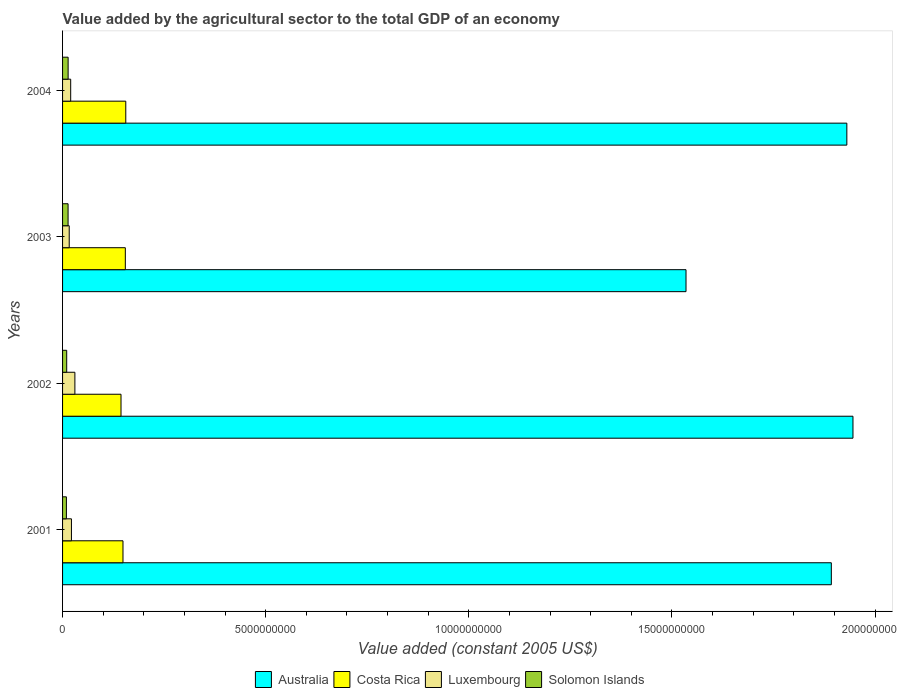How many groups of bars are there?
Provide a succinct answer. 4. Are the number of bars per tick equal to the number of legend labels?
Your answer should be very brief. Yes. Are the number of bars on each tick of the Y-axis equal?
Offer a terse response. Yes. What is the label of the 1st group of bars from the top?
Keep it short and to the point. 2004. In how many cases, is the number of bars for a given year not equal to the number of legend labels?
Provide a succinct answer. 0. What is the value added by the agricultural sector in Solomon Islands in 2001?
Offer a terse response. 9.47e+07. Across all years, what is the maximum value added by the agricultural sector in Costa Rica?
Make the answer very short. 1.56e+09. Across all years, what is the minimum value added by the agricultural sector in Luxembourg?
Provide a succinct answer. 1.64e+08. In which year was the value added by the agricultural sector in Australia minimum?
Ensure brevity in your answer.  2003. What is the total value added by the agricultural sector in Australia in the graph?
Offer a very short reply. 7.30e+1. What is the difference between the value added by the agricultural sector in Luxembourg in 2001 and that in 2003?
Provide a succinct answer. 5.45e+07. What is the difference between the value added by the agricultural sector in Solomon Islands in 2004 and the value added by the agricultural sector in Costa Rica in 2002?
Your answer should be very brief. -1.30e+09. What is the average value added by the agricultural sector in Australia per year?
Your answer should be very brief. 1.83e+1. In the year 2003, what is the difference between the value added by the agricultural sector in Costa Rica and value added by the agricultural sector in Solomon Islands?
Offer a very short reply. 1.41e+09. What is the ratio of the value added by the agricultural sector in Luxembourg in 2003 to that in 2004?
Provide a succinct answer. 0.82. Is the value added by the agricultural sector in Luxembourg in 2001 less than that in 2004?
Offer a very short reply. No. Is the difference between the value added by the agricultural sector in Costa Rica in 2001 and 2002 greater than the difference between the value added by the agricultural sector in Solomon Islands in 2001 and 2002?
Ensure brevity in your answer.  Yes. What is the difference between the highest and the second highest value added by the agricultural sector in Solomon Islands?
Give a very brief answer. 1.15e+06. What is the difference between the highest and the lowest value added by the agricultural sector in Luxembourg?
Provide a succinct answer. 1.39e+08. In how many years, is the value added by the agricultural sector in Costa Rica greater than the average value added by the agricultural sector in Costa Rica taken over all years?
Make the answer very short. 2. Is it the case that in every year, the sum of the value added by the agricultural sector in Costa Rica and value added by the agricultural sector in Solomon Islands is greater than the sum of value added by the agricultural sector in Australia and value added by the agricultural sector in Luxembourg?
Offer a very short reply. Yes. What does the 3rd bar from the top in 2003 represents?
Keep it short and to the point. Costa Rica. What does the 3rd bar from the bottom in 2001 represents?
Offer a terse response. Luxembourg. Is it the case that in every year, the sum of the value added by the agricultural sector in Solomon Islands and value added by the agricultural sector in Australia is greater than the value added by the agricultural sector in Costa Rica?
Make the answer very short. Yes. Are all the bars in the graph horizontal?
Keep it short and to the point. Yes. Does the graph contain grids?
Offer a very short reply. No. What is the title of the graph?
Provide a succinct answer. Value added by the agricultural sector to the total GDP of an economy. Does "Marshall Islands" appear as one of the legend labels in the graph?
Your answer should be compact. No. What is the label or title of the X-axis?
Give a very brief answer. Value added (constant 2005 US$). What is the Value added (constant 2005 US$) of Australia in 2001?
Provide a succinct answer. 1.89e+1. What is the Value added (constant 2005 US$) in Costa Rica in 2001?
Ensure brevity in your answer.  1.49e+09. What is the Value added (constant 2005 US$) of Luxembourg in 2001?
Ensure brevity in your answer.  2.18e+08. What is the Value added (constant 2005 US$) in Solomon Islands in 2001?
Offer a terse response. 9.47e+07. What is the Value added (constant 2005 US$) in Australia in 2002?
Offer a terse response. 1.95e+1. What is the Value added (constant 2005 US$) of Costa Rica in 2002?
Offer a terse response. 1.44e+09. What is the Value added (constant 2005 US$) of Luxembourg in 2002?
Keep it short and to the point. 3.03e+08. What is the Value added (constant 2005 US$) in Solomon Islands in 2002?
Provide a short and direct response. 1.02e+08. What is the Value added (constant 2005 US$) of Australia in 2003?
Your answer should be very brief. 1.53e+1. What is the Value added (constant 2005 US$) of Costa Rica in 2003?
Offer a very short reply. 1.54e+09. What is the Value added (constant 2005 US$) in Luxembourg in 2003?
Provide a short and direct response. 1.64e+08. What is the Value added (constant 2005 US$) in Solomon Islands in 2003?
Your response must be concise. 1.36e+08. What is the Value added (constant 2005 US$) of Australia in 2004?
Your answer should be compact. 1.93e+1. What is the Value added (constant 2005 US$) in Costa Rica in 2004?
Provide a succinct answer. 1.56e+09. What is the Value added (constant 2005 US$) of Luxembourg in 2004?
Give a very brief answer. 2.00e+08. What is the Value added (constant 2005 US$) in Solomon Islands in 2004?
Offer a terse response. 1.37e+08. Across all years, what is the maximum Value added (constant 2005 US$) of Australia?
Give a very brief answer. 1.95e+1. Across all years, what is the maximum Value added (constant 2005 US$) of Costa Rica?
Provide a short and direct response. 1.56e+09. Across all years, what is the maximum Value added (constant 2005 US$) of Luxembourg?
Offer a terse response. 3.03e+08. Across all years, what is the maximum Value added (constant 2005 US$) in Solomon Islands?
Make the answer very short. 1.37e+08. Across all years, what is the minimum Value added (constant 2005 US$) of Australia?
Keep it short and to the point. 1.53e+1. Across all years, what is the minimum Value added (constant 2005 US$) in Costa Rica?
Keep it short and to the point. 1.44e+09. Across all years, what is the minimum Value added (constant 2005 US$) in Luxembourg?
Provide a short and direct response. 1.64e+08. Across all years, what is the minimum Value added (constant 2005 US$) in Solomon Islands?
Ensure brevity in your answer.  9.47e+07. What is the total Value added (constant 2005 US$) of Australia in the graph?
Keep it short and to the point. 7.30e+1. What is the total Value added (constant 2005 US$) in Costa Rica in the graph?
Your response must be concise. 6.03e+09. What is the total Value added (constant 2005 US$) of Luxembourg in the graph?
Ensure brevity in your answer.  8.85e+08. What is the total Value added (constant 2005 US$) in Solomon Islands in the graph?
Keep it short and to the point. 4.69e+08. What is the difference between the Value added (constant 2005 US$) in Australia in 2001 and that in 2002?
Your answer should be compact. -5.33e+08. What is the difference between the Value added (constant 2005 US$) in Costa Rica in 2001 and that in 2002?
Your response must be concise. 4.85e+07. What is the difference between the Value added (constant 2005 US$) in Luxembourg in 2001 and that in 2002?
Keep it short and to the point. -8.48e+07. What is the difference between the Value added (constant 2005 US$) of Solomon Islands in 2001 and that in 2002?
Your response must be concise. -7.30e+06. What is the difference between the Value added (constant 2005 US$) of Australia in 2001 and that in 2003?
Your answer should be very brief. 3.58e+09. What is the difference between the Value added (constant 2005 US$) in Costa Rica in 2001 and that in 2003?
Offer a very short reply. -5.76e+07. What is the difference between the Value added (constant 2005 US$) of Luxembourg in 2001 and that in 2003?
Your answer should be very brief. 5.45e+07. What is the difference between the Value added (constant 2005 US$) of Solomon Islands in 2001 and that in 2003?
Keep it short and to the point. -4.10e+07. What is the difference between the Value added (constant 2005 US$) in Australia in 2001 and that in 2004?
Provide a succinct answer. -3.82e+08. What is the difference between the Value added (constant 2005 US$) in Costa Rica in 2001 and that in 2004?
Your answer should be compact. -6.88e+07. What is the difference between the Value added (constant 2005 US$) in Luxembourg in 2001 and that in 2004?
Provide a short and direct response. 1.85e+07. What is the difference between the Value added (constant 2005 US$) in Solomon Islands in 2001 and that in 2004?
Make the answer very short. -4.22e+07. What is the difference between the Value added (constant 2005 US$) of Australia in 2002 and that in 2003?
Make the answer very short. 4.11e+09. What is the difference between the Value added (constant 2005 US$) of Costa Rica in 2002 and that in 2003?
Offer a very short reply. -1.06e+08. What is the difference between the Value added (constant 2005 US$) of Luxembourg in 2002 and that in 2003?
Make the answer very short. 1.39e+08. What is the difference between the Value added (constant 2005 US$) of Solomon Islands in 2002 and that in 2003?
Keep it short and to the point. -3.37e+07. What is the difference between the Value added (constant 2005 US$) in Australia in 2002 and that in 2004?
Offer a very short reply. 1.51e+08. What is the difference between the Value added (constant 2005 US$) in Costa Rica in 2002 and that in 2004?
Offer a very short reply. -1.17e+08. What is the difference between the Value added (constant 2005 US$) in Luxembourg in 2002 and that in 2004?
Offer a very short reply. 1.03e+08. What is the difference between the Value added (constant 2005 US$) in Solomon Islands in 2002 and that in 2004?
Ensure brevity in your answer.  -3.49e+07. What is the difference between the Value added (constant 2005 US$) in Australia in 2003 and that in 2004?
Offer a terse response. -3.96e+09. What is the difference between the Value added (constant 2005 US$) of Costa Rica in 2003 and that in 2004?
Offer a terse response. -1.12e+07. What is the difference between the Value added (constant 2005 US$) in Luxembourg in 2003 and that in 2004?
Offer a very short reply. -3.60e+07. What is the difference between the Value added (constant 2005 US$) of Solomon Islands in 2003 and that in 2004?
Ensure brevity in your answer.  -1.15e+06. What is the difference between the Value added (constant 2005 US$) in Australia in 2001 and the Value added (constant 2005 US$) in Costa Rica in 2002?
Your answer should be compact. 1.75e+1. What is the difference between the Value added (constant 2005 US$) in Australia in 2001 and the Value added (constant 2005 US$) in Luxembourg in 2002?
Provide a short and direct response. 1.86e+1. What is the difference between the Value added (constant 2005 US$) of Australia in 2001 and the Value added (constant 2005 US$) of Solomon Islands in 2002?
Your answer should be compact. 1.88e+1. What is the difference between the Value added (constant 2005 US$) of Costa Rica in 2001 and the Value added (constant 2005 US$) of Luxembourg in 2002?
Your answer should be very brief. 1.18e+09. What is the difference between the Value added (constant 2005 US$) in Costa Rica in 2001 and the Value added (constant 2005 US$) in Solomon Islands in 2002?
Your response must be concise. 1.39e+09. What is the difference between the Value added (constant 2005 US$) of Luxembourg in 2001 and the Value added (constant 2005 US$) of Solomon Islands in 2002?
Give a very brief answer. 1.16e+08. What is the difference between the Value added (constant 2005 US$) of Australia in 2001 and the Value added (constant 2005 US$) of Costa Rica in 2003?
Provide a succinct answer. 1.74e+1. What is the difference between the Value added (constant 2005 US$) in Australia in 2001 and the Value added (constant 2005 US$) in Luxembourg in 2003?
Your response must be concise. 1.88e+1. What is the difference between the Value added (constant 2005 US$) in Australia in 2001 and the Value added (constant 2005 US$) in Solomon Islands in 2003?
Provide a short and direct response. 1.88e+1. What is the difference between the Value added (constant 2005 US$) in Costa Rica in 2001 and the Value added (constant 2005 US$) in Luxembourg in 2003?
Ensure brevity in your answer.  1.32e+09. What is the difference between the Value added (constant 2005 US$) in Costa Rica in 2001 and the Value added (constant 2005 US$) in Solomon Islands in 2003?
Give a very brief answer. 1.35e+09. What is the difference between the Value added (constant 2005 US$) of Luxembourg in 2001 and the Value added (constant 2005 US$) of Solomon Islands in 2003?
Your response must be concise. 8.27e+07. What is the difference between the Value added (constant 2005 US$) in Australia in 2001 and the Value added (constant 2005 US$) in Costa Rica in 2004?
Your answer should be very brief. 1.74e+1. What is the difference between the Value added (constant 2005 US$) in Australia in 2001 and the Value added (constant 2005 US$) in Luxembourg in 2004?
Offer a very short reply. 1.87e+1. What is the difference between the Value added (constant 2005 US$) of Australia in 2001 and the Value added (constant 2005 US$) of Solomon Islands in 2004?
Provide a short and direct response. 1.88e+1. What is the difference between the Value added (constant 2005 US$) of Costa Rica in 2001 and the Value added (constant 2005 US$) of Luxembourg in 2004?
Ensure brevity in your answer.  1.29e+09. What is the difference between the Value added (constant 2005 US$) in Costa Rica in 2001 and the Value added (constant 2005 US$) in Solomon Islands in 2004?
Make the answer very short. 1.35e+09. What is the difference between the Value added (constant 2005 US$) of Luxembourg in 2001 and the Value added (constant 2005 US$) of Solomon Islands in 2004?
Your response must be concise. 8.15e+07. What is the difference between the Value added (constant 2005 US$) in Australia in 2002 and the Value added (constant 2005 US$) in Costa Rica in 2003?
Ensure brevity in your answer.  1.79e+1. What is the difference between the Value added (constant 2005 US$) of Australia in 2002 and the Value added (constant 2005 US$) of Luxembourg in 2003?
Offer a very short reply. 1.93e+1. What is the difference between the Value added (constant 2005 US$) in Australia in 2002 and the Value added (constant 2005 US$) in Solomon Islands in 2003?
Make the answer very short. 1.93e+1. What is the difference between the Value added (constant 2005 US$) in Costa Rica in 2002 and the Value added (constant 2005 US$) in Luxembourg in 2003?
Offer a terse response. 1.27e+09. What is the difference between the Value added (constant 2005 US$) of Costa Rica in 2002 and the Value added (constant 2005 US$) of Solomon Islands in 2003?
Give a very brief answer. 1.30e+09. What is the difference between the Value added (constant 2005 US$) of Luxembourg in 2002 and the Value added (constant 2005 US$) of Solomon Islands in 2003?
Your answer should be compact. 1.67e+08. What is the difference between the Value added (constant 2005 US$) of Australia in 2002 and the Value added (constant 2005 US$) of Costa Rica in 2004?
Ensure brevity in your answer.  1.79e+1. What is the difference between the Value added (constant 2005 US$) in Australia in 2002 and the Value added (constant 2005 US$) in Luxembourg in 2004?
Provide a short and direct response. 1.93e+1. What is the difference between the Value added (constant 2005 US$) of Australia in 2002 and the Value added (constant 2005 US$) of Solomon Islands in 2004?
Give a very brief answer. 1.93e+1. What is the difference between the Value added (constant 2005 US$) in Costa Rica in 2002 and the Value added (constant 2005 US$) in Luxembourg in 2004?
Give a very brief answer. 1.24e+09. What is the difference between the Value added (constant 2005 US$) in Costa Rica in 2002 and the Value added (constant 2005 US$) in Solomon Islands in 2004?
Your answer should be compact. 1.30e+09. What is the difference between the Value added (constant 2005 US$) in Luxembourg in 2002 and the Value added (constant 2005 US$) in Solomon Islands in 2004?
Your answer should be compact. 1.66e+08. What is the difference between the Value added (constant 2005 US$) of Australia in 2003 and the Value added (constant 2005 US$) of Costa Rica in 2004?
Keep it short and to the point. 1.38e+1. What is the difference between the Value added (constant 2005 US$) of Australia in 2003 and the Value added (constant 2005 US$) of Luxembourg in 2004?
Offer a very short reply. 1.51e+1. What is the difference between the Value added (constant 2005 US$) of Australia in 2003 and the Value added (constant 2005 US$) of Solomon Islands in 2004?
Offer a very short reply. 1.52e+1. What is the difference between the Value added (constant 2005 US$) of Costa Rica in 2003 and the Value added (constant 2005 US$) of Luxembourg in 2004?
Offer a very short reply. 1.34e+09. What is the difference between the Value added (constant 2005 US$) of Costa Rica in 2003 and the Value added (constant 2005 US$) of Solomon Islands in 2004?
Keep it short and to the point. 1.41e+09. What is the difference between the Value added (constant 2005 US$) in Luxembourg in 2003 and the Value added (constant 2005 US$) in Solomon Islands in 2004?
Provide a succinct answer. 2.70e+07. What is the average Value added (constant 2005 US$) of Australia per year?
Provide a short and direct response. 1.83e+1. What is the average Value added (constant 2005 US$) of Costa Rica per year?
Your response must be concise. 1.51e+09. What is the average Value added (constant 2005 US$) in Luxembourg per year?
Give a very brief answer. 2.21e+08. What is the average Value added (constant 2005 US$) of Solomon Islands per year?
Give a very brief answer. 1.17e+08. In the year 2001, what is the difference between the Value added (constant 2005 US$) of Australia and Value added (constant 2005 US$) of Costa Rica?
Ensure brevity in your answer.  1.74e+1. In the year 2001, what is the difference between the Value added (constant 2005 US$) of Australia and Value added (constant 2005 US$) of Luxembourg?
Offer a very short reply. 1.87e+1. In the year 2001, what is the difference between the Value added (constant 2005 US$) of Australia and Value added (constant 2005 US$) of Solomon Islands?
Your answer should be very brief. 1.88e+1. In the year 2001, what is the difference between the Value added (constant 2005 US$) of Costa Rica and Value added (constant 2005 US$) of Luxembourg?
Keep it short and to the point. 1.27e+09. In the year 2001, what is the difference between the Value added (constant 2005 US$) of Costa Rica and Value added (constant 2005 US$) of Solomon Islands?
Your answer should be very brief. 1.39e+09. In the year 2001, what is the difference between the Value added (constant 2005 US$) of Luxembourg and Value added (constant 2005 US$) of Solomon Islands?
Offer a terse response. 1.24e+08. In the year 2002, what is the difference between the Value added (constant 2005 US$) of Australia and Value added (constant 2005 US$) of Costa Rica?
Keep it short and to the point. 1.80e+1. In the year 2002, what is the difference between the Value added (constant 2005 US$) in Australia and Value added (constant 2005 US$) in Luxembourg?
Keep it short and to the point. 1.92e+1. In the year 2002, what is the difference between the Value added (constant 2005 US$) of Australia and Value added (constant 2005 US$) of Solomon Islands?
Your answer should be compact. 1.94e+1. In the year 2002, what is the difference between the Value added (constant 2005 US$) in Costa Rica and Value added (constant 2005 US$) in Luxembourg?
Give a very brief answer. 1.14e+09. In the year 2002, what is the difference between the Value added (constant 2005 US$) of Costa Rica and Value added (constant 2005 US$) of Solomon Islands?
Your answer should be very brief. 1.34e+09. In the year 2002, what is the difference between the Value added (constant 2005 US$) of Luxembourg and Value added (constant 2005 US$) of Solomon Islands?
Make the answer very short. 2.01e+08. In the year 2003, what is the difference between the Value added (constant 2005 US$) of Australia and Value added (constant 2005 US$) of Costa Rica?
Make the answer very short. 1.38e+1. In the year 2003, what is the difference between the Value added (constant 2005 US$) of Australia and Value added (constant 2005 US$) of Luxembourg?
Your answer should be very brief. 1.52e+1. In the year 2003, what is the difference between the Value added (constant 2005 US$) of Australia and Value added (constant 2005 US$) of Solomon Islands?
Give a very brief answer. 1.52e+1. In the year 2003, what is the difference between the Value added (constant 2005 US$) in Costa Rica and Value added (constant 2005 US$) in Luxembourg?
Offer a terse response. 1.38e+09. In the year 2003, what is the difference between the Value added (constant 2005 US$) of Costa Rica and Value added (constant 2005 US$) of Solomon Islands?
Give a very brief answer. 1.41e+09. In the year 2003, what is the difference between the Value added (constant 2005 US$) of Luxembourg and Value added (constant 2005 US$) of Solomon Islands?
Your answer should be very brief. 2.82e+07. In the year 2004, what is the difference between the Value added (constant 2005 US$) in Australia and Value added (constant 2005 US$) in Costa Rica?
Offer a very short reply. 1.77e+1. In the year 2004, what is the difference between the Value added (constant 2005 US$) in Australia and Value added (constant 2005 US$) in Luxembourg?
Give a very brief answer. 1.91e+1. In the year 2004, what is the difference between the Value added (constant 2005 US$) of Australia and Value added (constant 2005 US$) of Solomon Islands?
Keep it short and to the point. 1.92e+1. In the year 2004, what is the difference between the Value added (constant 2005 US$) of Costa Rica and Value added (constant 2005 US$) of Luxembourg?
Ensure brevity in your answer.  1.36e+09. In the year 2004, what is the difference between the Value added (constant 2005 US$) in Costa Rica and Value added (constant 2005 US$) in Solomon Islands?
Make the answer very short. 1.42e+09. In the year 2004, what is the difference between the Value added (constant 2005 US$) of Luxembourg and Value added (constant 2005 US$) of Solomon Islands?
Give a very brief answer. 6.30e+07. What is the ratio of the Value added (constant 2005 US$) in Australia in 2001 to that in 2002?
Offer a very short reply. 0.97. What is the ratio of the Value added (constant 2005 US$) in Costa Rica in 2001 to that in 2002?
Ensure brevity in your answer.  1.03. What is the ratio of the Value added (constant 2005 US$) of Luxembourg in 2001 to that in 2002?
Give a very brief answer. 0.72. What is the ratio of the Value added (constant 2005 US$) in Solomon Islands in 2001 to that in 2002?
Your answer should be very brief. 0.93. What is the ratio of the Value added (constant 2005 US$) of Australia in 2001 to that in 2003?
Offer a very short reply. 1.23. What is the ratio of the Value added (constant 2005 US$) of Costa Rica in 2001 to that in 2003?
Your answer should be very brief. 0.96. What is the ratio of the Value added (constant 2005 US$) in Luxembourg in 2001 to that in 2003?
Provide a succinct answer. 1.33. What is the ratio of the Value added (constant 2005 US$) of Solomon Islands in 2001 to that in 2003?
Your answer should be compact. 0.7. What is the ratio of the Value added (constant 2005 US$) in Australia in 2001 to that in 2004?
Keep it short and to the point. 0.98. What is the ratio of the Value added (constant 2005 US$) of Costa Rica in 2001 to that in 2004?
Provide a short and direct response. 0.96. What is the ratio of the Value added (constant 2005 US$) in Luxembourg in 2001 to that in 2004?
Provide a succinct answer. 1.09. What is the ratio of the Value added (constant 2005 US$) of Solomon Islands in 2001 to that in 2004?
Provide a succinct answer. 0.69. What is the ratio of the Value added (constant 2005 US$) of Australia in 2002 to that in 2003?
Make the answer very short. 1.27. What is the ratio of the Value added (constant 2005 US$) of Costa Rica in 2002 to that in 2003?
Your answer should be very brief. 0.93. What is the ratio of the Value added (constant 2005 US$) in Luxembourg in 2002 to that in 2003?
Provide a succinct answer. 1.85. What is the ratio of the Value added (constant 2005 US$) of Solomon Islands in 2002 to that in 2003?
Your answer should be compact. 0.75. What is the ratio of the Value added (constant 2005 US$) of Australia in 2002 to that in 2004?
Give a very brief answer. 1.01. What is the ratio of the Value added (constant 2005 US$) of Costa Rica in 2002 to that in 2004?
Ensure brevity in your answer.  0.92. What is the ratio of the Value added (constant 2005 US$) of Luxembourg in 2002 to that in 2004?
Provide a succinct answer. 1.52. What is the ratio of the Value added (constant 2005 US$) of Solomon Islands in 2002 to that in 2004?
Your answer should be compact. 0.74. What is the ratio of the Value added (constant 2005 US$) in Australia in 2003 to that in 2004?
Your response must be concise. 0.79. What is the ratio of the Value added (constant 2005 US$) of Luxembourg in 2003 to that in 2004?
Your answer should be compact. 0.82. What is the difference between the highest and the second highest Value added (constant 2005 US$) of Australia?
Provide a short and direct response. 1.51e+08. What is the difference between the highest and the second highest Value added (constant 2005 US$) of Costa Rica?
Your answer should be very brief. 1.12e+07. What is the difference between the highest and the second highest Value added (constant 2005 US$) of Luxembourg?
Give a very brief answer. 8.48e+07. What is the difference between the highest and the second highest Value added (constant 2005 US$) of Solomon Islands?
Offer a very short reply. 1.15e+06. What is the difference between the highest and the lowest Value added (constant 2005 US$) of Australia?
Offer a very short reply. 4.11e+09. What is the difference between the highest and the lowest Value added (constant 2005 US$) of Costa Rica?
Give a very brief answer. 1.17e+08. What is the difference between the highest and the lowest Value added (constant 2005 US$) of Luxembourg?
Your answer should be very brief. 1.39e+08. What is the difference between the highest and the lowest Value added (constant 2005 US$) of Solomon Islands?
Offer a very short reply. 4.22e+07. 